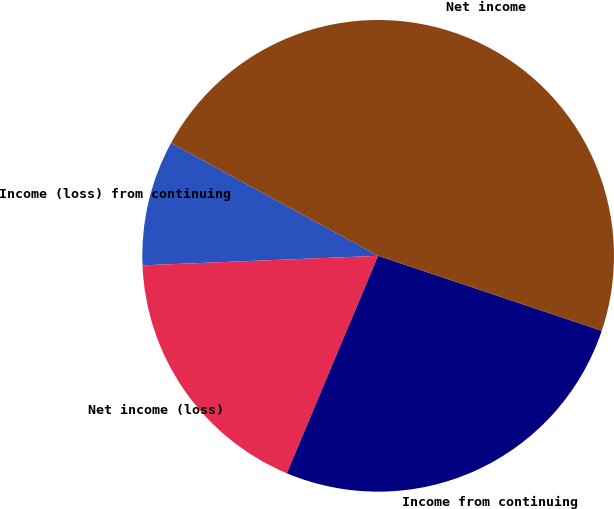Convert chart. <chart><loc_0><loc_0><loc_500><loc_500><pie_chart><fcel>Income (loss) from continuing<fcel>Net income (loss)<fcel>Income from continuing<fcel>Net income<nl><fcel>8.58%<fcel>18.03%<fcel>26.18%<fcel>47.21%<nl></chart> 